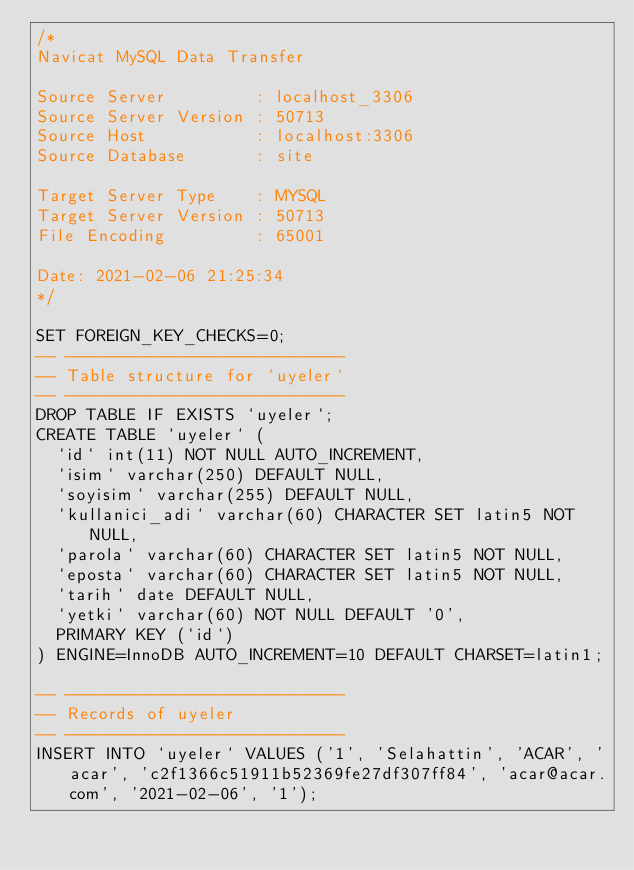Convert code to text. <code><loc_0><loc_0><loc_500><loc_500><_SQL_>/*
Navicat MySQL Data Transfer

Source Server         : localhost_3306
Source Server Version : 50713
Source Host           : localhost:3306
Source Database       : site

Target Server Type    : MYSQL
Target Server Version : 50713
File Encoding         : 65001

Date: 2021-02-06 21:25:34
*/

SET FOREIGN_KEY_CHECKS=0;
-- ----------------------------
-- Table structure for `uyeler`
-- ----------------------------
DROP TABLE IF EXISTS `uyeler`;
CREATE TABLE `uyeler` (
  `id` int(11) NOT NULL AUTO_INCREMENT,
  `isim` varchar(250) DEFAULT NULL,
  `soyisim` varchar(255) DEFAULT NULL,
  `kullanici_adi` varchar(60) CHARACTER SET latin5 NOT NULL,
  `parola` varchar(60) CHARACTER SET latin5 NOT NULL,
  `eposta` varchar(60) CHARACTER SET latin5 NOT NULL,
  `tarih` date DEFAULT NULL,
  `yetki` varchar(60) NOT NULL DEFAULT '0',
  PRIMARY KEY (`id`)
) ENGINE=InnoDB AUTO_INCREMENT=10 DEFAULT CHARSET=latin1;

-- ----------------------------
-- Records of uyeler
-- ----------------------------
INSERT INTO `uyeler` VALUES ('1', 'Selahattin', 'ACAR', 'acar', 'c2f1366c51911b52369fe27df307ff84', 'acar@acar.com', '2021-02-06', '1');
</code> 